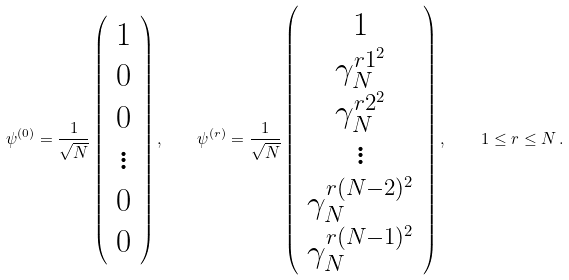<formula> <loc_0><loc_0><loc_500><loc_500>\psi ^ { ( 0 ) } = \frac { 1 } { \sqrt { N } } \left ( \begin{array} { c } 1 \\ 0 \\ 0 \\ \vdots \\ 0 \\ 0 \end{array} \right ) , \quad \psi ^ { ( r ) } = \frac { 1 } { \sqrt { N } } \left ( \begin{array} { c } 1 \\ \gamma _ { N } ^ { r 1 ^ { 2 } } \\ \gamma _ { N } ^ { r 2 ^ { 2 } } \\ \vdots \\ \gamma _ { N } ^ { r ( N - 2 ) ^ { 2 } } \\ \gamma _ { N } ^ { r ( N - 1 ) ^ { 2 } } \end{array} \right ) , \quad 1 \leq r \leq N \, .</formula> 